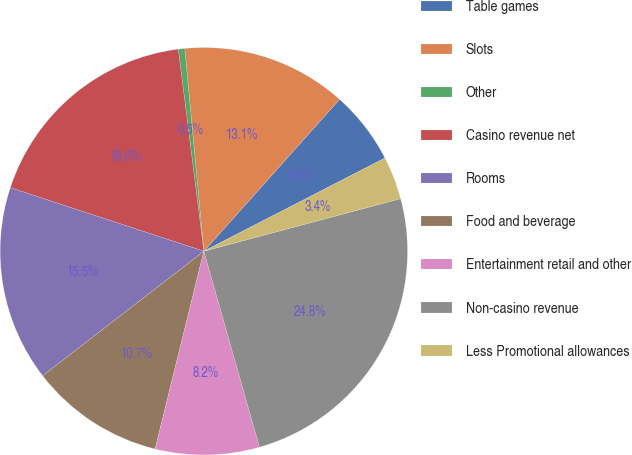Convert chart. <chart><loc_0><loc_0><loc_500><loc_500><pie_chart><fcel>Table games<fcel>Slots<fcel>Other<fcel>Casino revenue net<fcel>Rooms<fcel>Food and beverage<fcel>Entertainment retail and other<fcel>Non-casino revenue<fcel>Less Promotional allowances<nl><fcel>5.83%<fcel>13.1%<fcel>0.51%<fcel>17.95%<fcel>15.52%<fcel>10.68%<fcel>8.25%<fcel>24.75%<fcel>3.41%<nl></chart> 